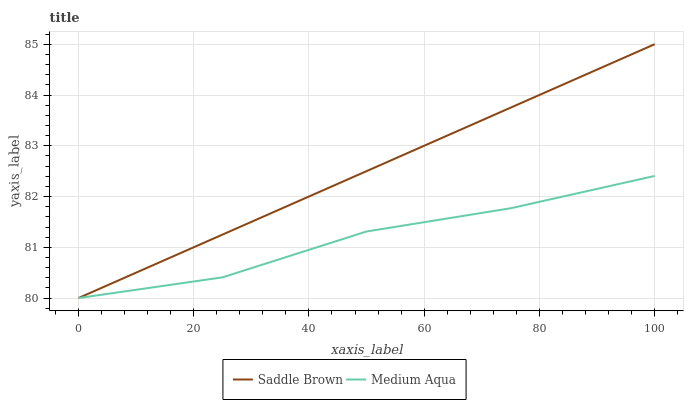Does Medium Aqua have the minimum area under the curve?
Answer yes or no. Yes. Does Saddle Brown have the maximum area under the curve?
Answer yes or no. Yes. Does Saddle Brown have the minimum area under the curve?
Answer yes or no. No. Is Saddle Brown the smoothest?
Answer yes or no. Yes. Is Medium Aqua the roughest?
Answer yes or no. Yes. Is Saddle Brown the roughest?
Answer yes or no. No. Does Medium Aqua have the lowest value?
Answer yes or no. Yes. Does Saddle Brown have the highest value?
Answer yes or no. Yes. Does Saddle Brown intersect Medium Aqua?
Answer yes or no. Yes. Is Saddle Brown less than Medium Aqua?
Answer yes or no. No. Is Saddle Brown greater than Medium Aqua?
Answer yes or no. No. 